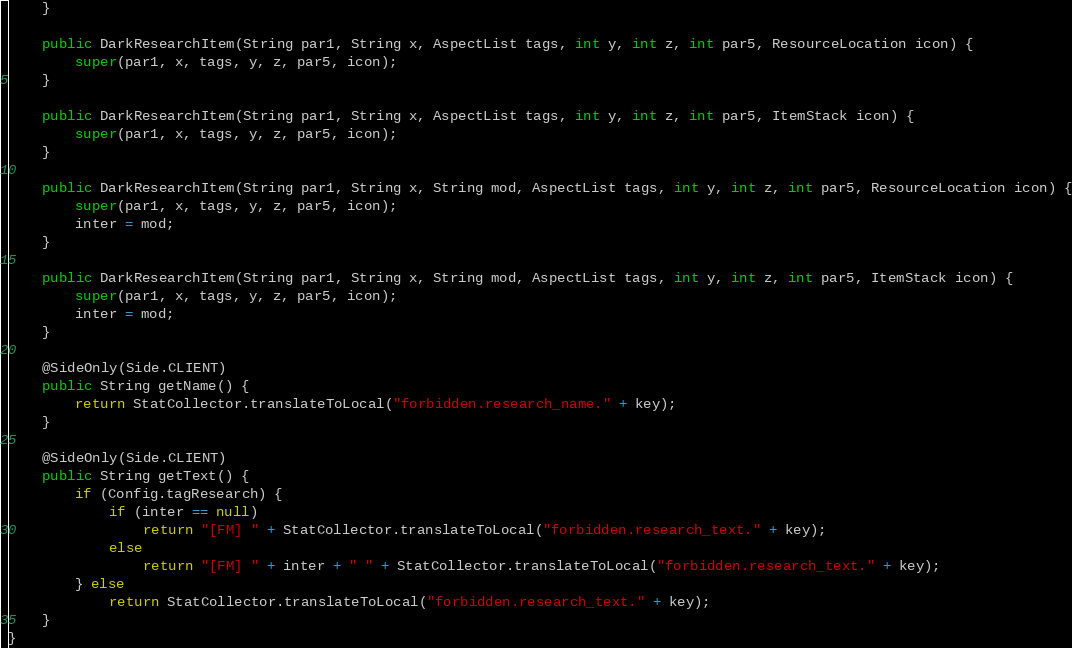Convert code to text. <code><loc_0><loc_0><loc_500><loc_500><_Java_>    }

    public DarkResearchItem(String par1, String x, AspectList tags, int y, int z, int par5, ResourceLocation icon) {
        super(par1, x, tags, y, z, par5, icon);
    }

    public DarkResearchItem(String par1, String x, AspectList tags, int y, int z, int par5, ItemStack icon) {
        super(par1, x, tags, y, z, par5, icon);
    }

    public DarkResearchItem(String par1, String x, String mod, AspectList tags, int y, int z, int par5, ResourceLocation icon) {
        super(par1, x, tags, y, z, par5, icon);
        inter = mod;
    }

    public DarkResearchItem(String par1, String x, String mod, AspectList tags, int y, int z, int par5, ItemStack icon) {
        super(par1, x, tags, y, z, par5, icon);
        inter = mod;
    }

    @SideOnly(Side.CLIENT)
    public String getName() {
        return StatCollector.translateToLocal("forbidden.research_name." + key);
    }

    @SideOnly(Side.CLIENT)
    public String getText() {
        if (Config.tagResearch) {
            if (inter == null)
                return "[FM] " + StatCollector.translateToLocal("forbidden.research_text." + key);
            else
                return "[FM] " + inter + " " + StatCollector.translateToLocal("forbidden.research_text." + key);
        } else
            return StatCollector.translateToLocal("forbidden.research_text." + key);
    }
}</code> 